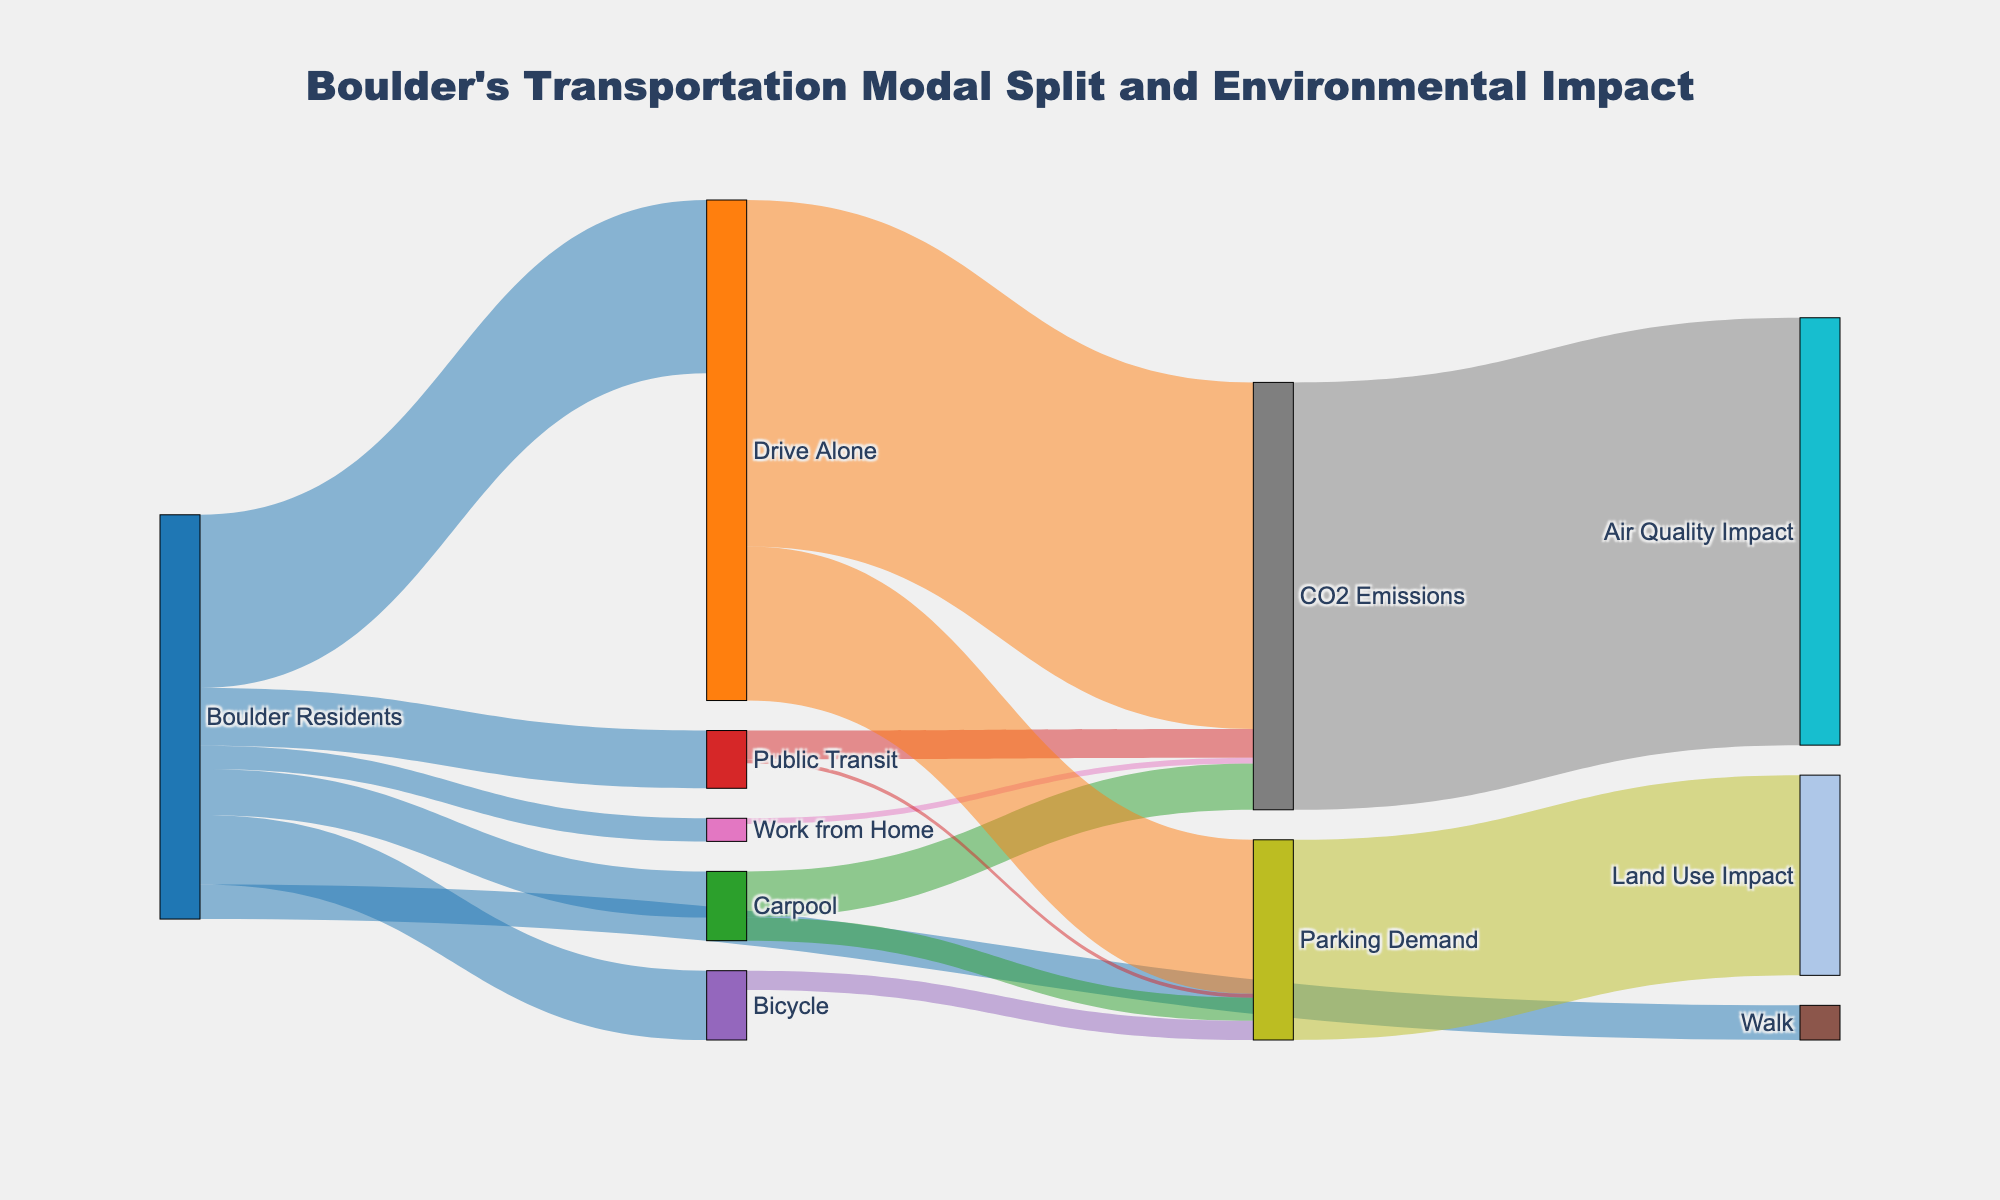What's the main title of the figure? The main title of the figure is displayed at the top and provides an overview of what the Sankey Diagram represents.
Answer: Boulder's Transportation Modal Split and Environmental Impact What transportation category do Boulder residents use the most? To determine the most used transportation category by Boulder residents, look for the source node with the highest value connected to Boulder Residents in the diagram.
Answer: Drive Alone How many people use environmentally friendly modes of transportation (Bicycle or Walk)? Add the values linked from Boulder Residents to Bicycle and Walk to get the total number of people using these modes.
Answer: 27000 Which transportation category results in the highest CO2 emissions? To find this, look for the target node labeled CO2 Emissions and identify the transportation category with the highest value linking to it.
Answer: Drive Alone What's the environmental impact shown for CO2 Emissions? Check the nodes connected to CO2 Emissions and identify the impact it results in.
Answer: Air Quality Impact How does Public Transit impact parking demand compared to Bicycle? Compare the values linked from Public Transit and Bicycle to Parking Demand.
Answer: Public Transit has lower parking demand What are the total CO2 emissions produced by Carpool and Public Transit combined? Add the values linked from Carpool and Public Transit to CO2 Emissions.
Answer: 19500 Which has a larger value, Land Use Impact or Air Quality Impact? Compare the values connected to Land Use Impact and Air Quality Impact.
Answer: Air Quality Impact What fraction of Boulder residents work from home, given the total number of Boulder residents? Divide the number of people working from home by the sum of all values linked from Boulder Residents and express it as a fraction.
Answer: 6,000/105,000 or approximately 0.057 Which mode of transportation is linked to having no CO2 emissions? Identify the modes of transportation connected to CO2 Emissions with a value of 0.
Answer: Bicycle and Walk 